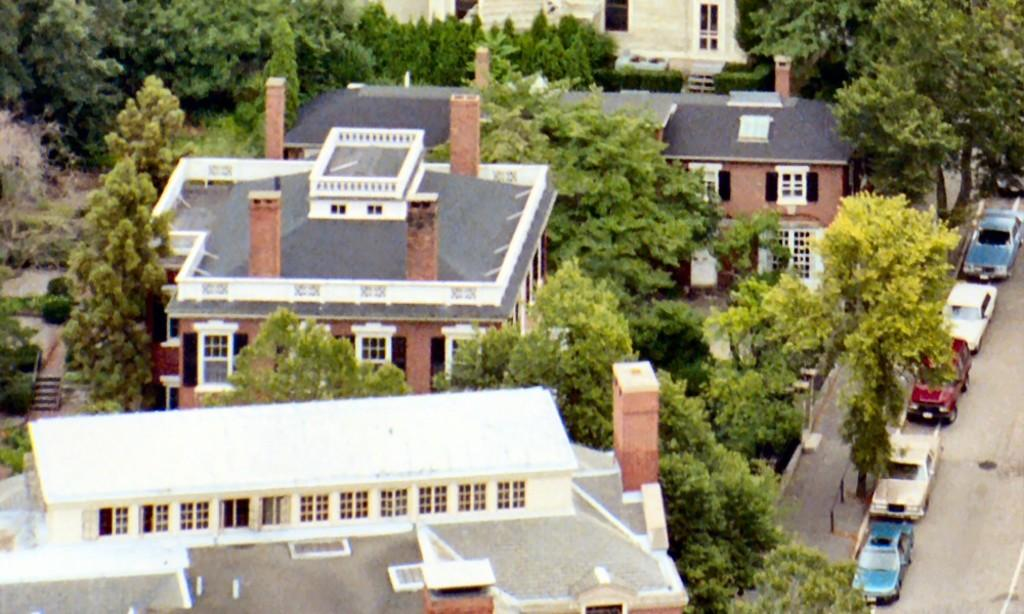What can be seen on the road in the image? There are cars on the road in the image. What is located on the pavement in the image? There are trees on the pavement in the image. What type of structures are visible in the image? There are buildings in the image. What is present between the buildings in the image? Trees are present between the buildings in the image. Can you see a nest of sisters in the trees between the buildings? There is no nest or sisters present in the image; it only features cars, trees, buildings, and roads. What type of leaf can be seen falling from the trees in the image? There is no leaf visible in the image; it only shows trees, buildings, and cars. 